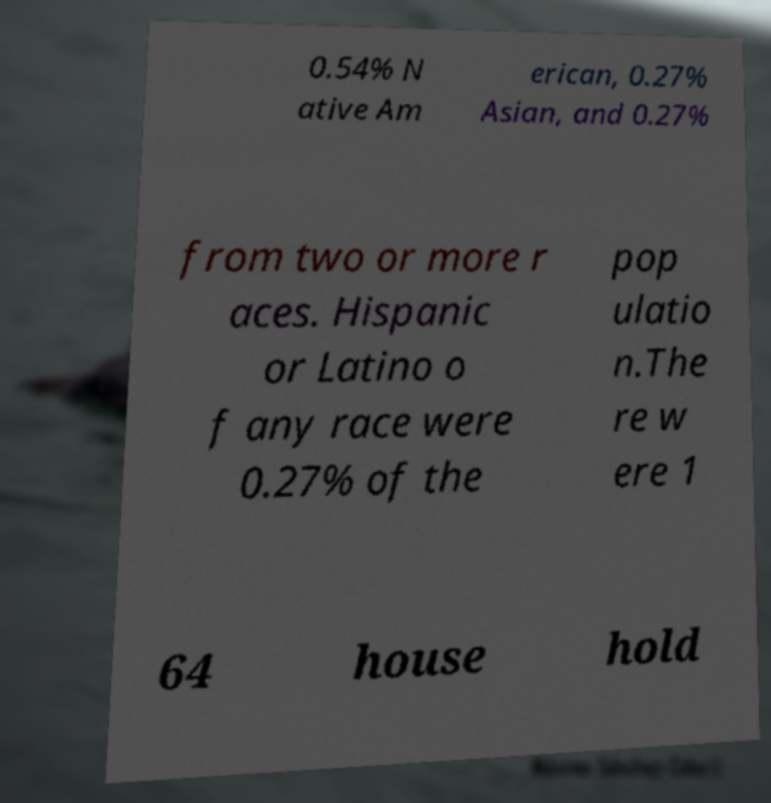Can you read and provide the text displayed in the image?This photo seems to have some interesting text. Can you extract and type it out for me? 0.54% N ative Am erican, 0.27% Asian, and 0.27% from two or more r aces. Hispanic or Latino o f any race were 0.27% of the pop ulatio n.The re w ere 1 64 house hold 